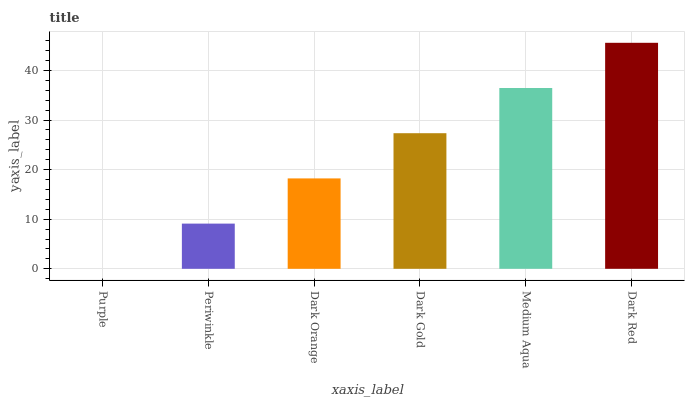Is Purple the minimum?
Answer yes or no. Yes. Is Dark Red the maximum?
Answer yes or no. Yes. Is Periwinkle the minimum?
Answer yes or no. No. Is Periwinkle the maximum?
Answer yes or no. No. Is Periwinkle greater than Purple?
Answer yes or no. Yes. Is Purple less than Periwinkle?
Answer yes or no. Yes. Is Purple greater than Periwinkle?
Answer yes or no. No. Is Periwinkle less than Purple?
Answer yes or no. No. Is Dark Gold the high median?
Answer yes or no. Yes. Is Dark Orange the low median?
Answer yes or no. Yes. Is Dark Orange the high median?
Answer yes or no. No. Is Purple the low median?
Answer yes or no. No. 